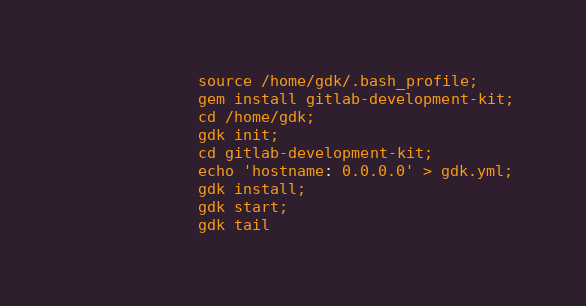Convert code to text. <code><loc_0><loc_0><loc_500><loc_500><_YAML_>              source /home/gdk/.bash_profile;
              gem install gitlab-development-kit;
              cd /home/gdk;
              gdk init;
              cd gitlab-development-kit;
              echo 'hostname: 0.0.0.0' > gdk.yml;
              gdk install;
              gdk start;
              gdk tail
</code> 